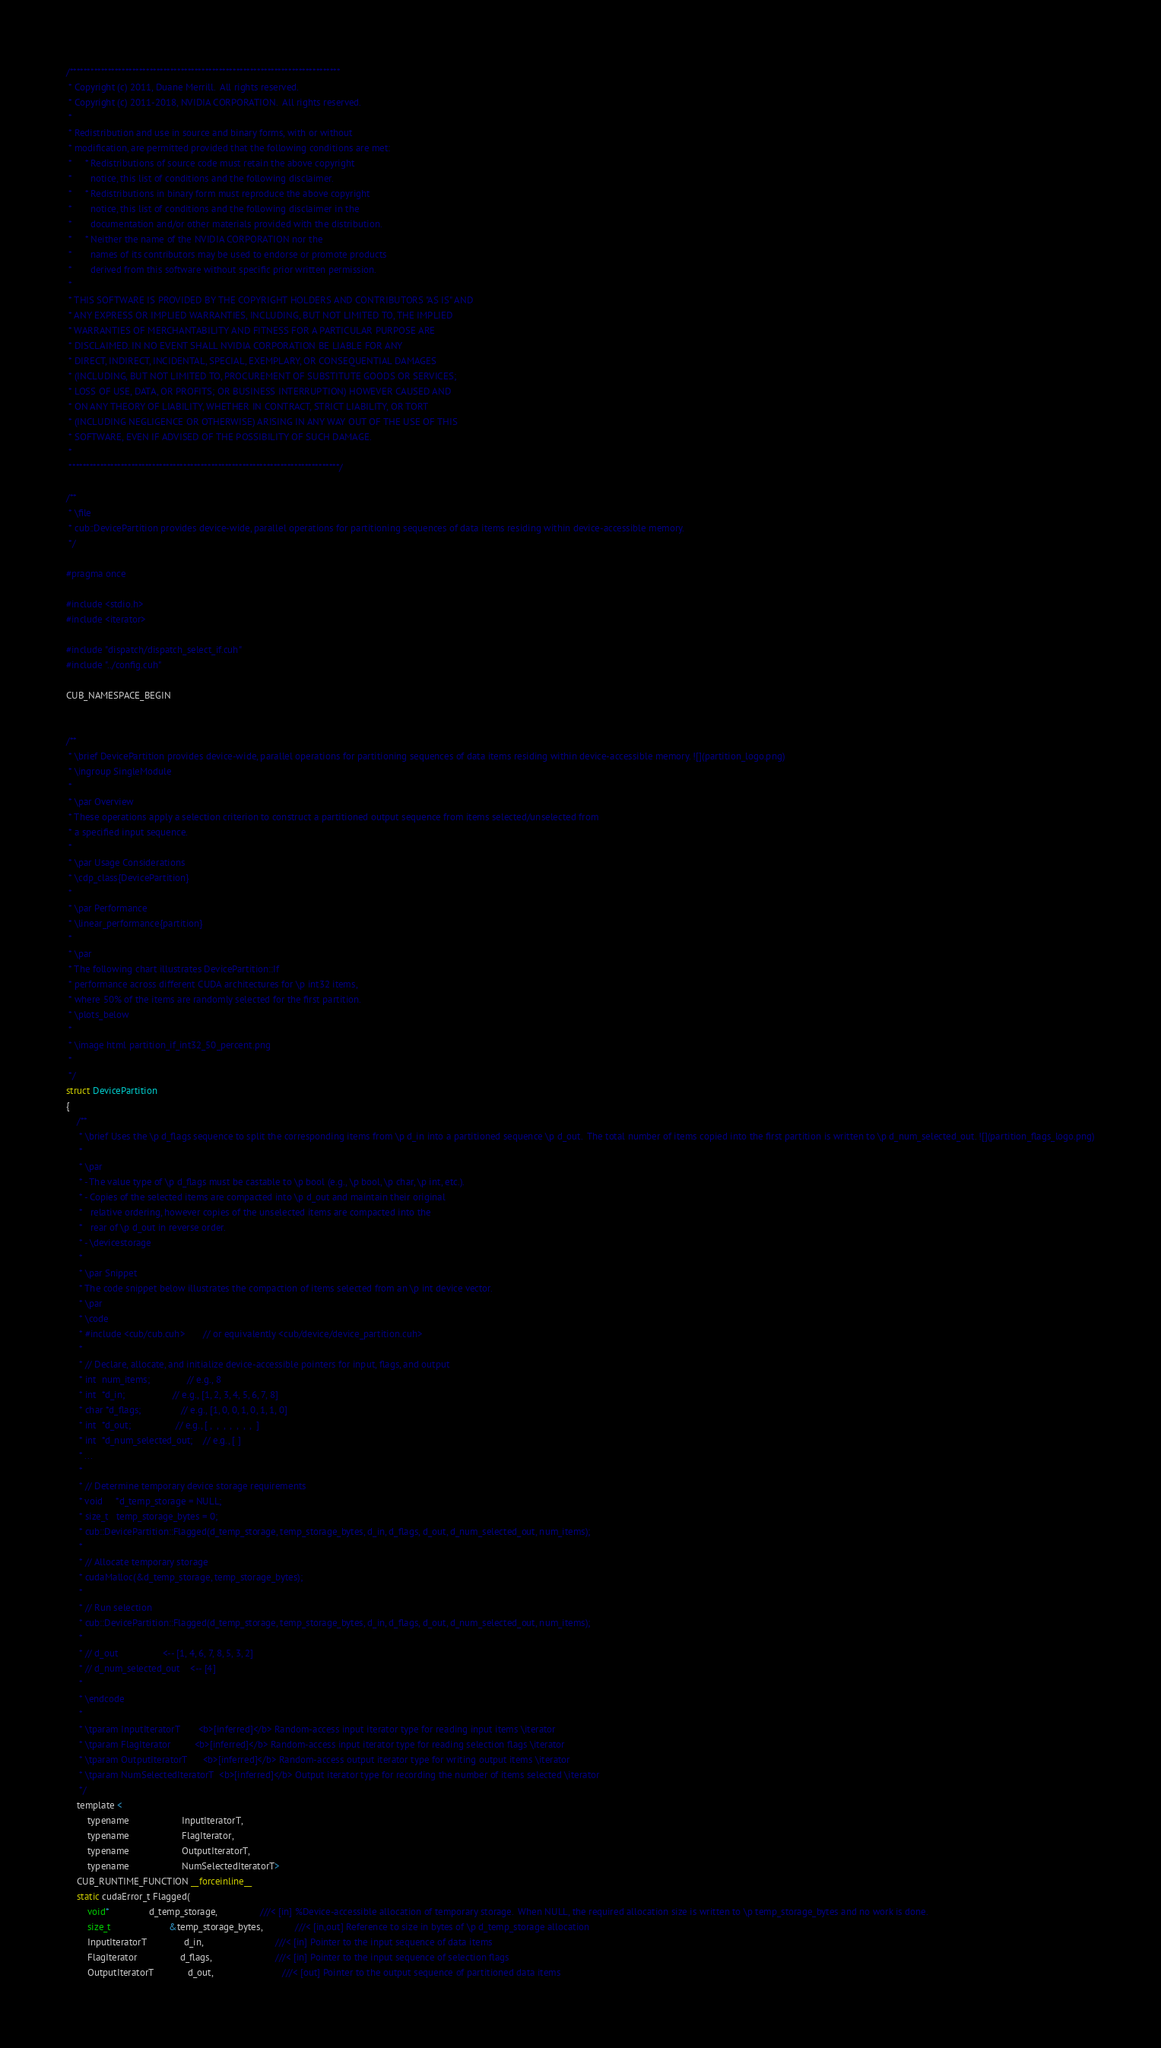Convert code to text. <code><loc_0><loc_0><loc_500><loc_500><_Cuda_>
/******************************************************************************
 * Copyright (c) 2011, Duane Merrill.  All rights reserved.
 * Copyright (c) 2011-2018, NVIDIA CORPORATION.  All rights reserved.
 *
 * Redistribution and use in source and binary forms, with or without
 * modification, are permitted provided that the following conditions are met:
 *     * Redistributions of source code must retain the above copyright
 *       notice, this list of conditions and the following disclaimer.
 *     * Redistributions in binary form must reproduce the above copyright
 *       notice, this list of conditions and the following disclaimer in the
 *       documentation and/or other materials provided with the distribution.
 *     * Neither the name of the NVIDIA CORPORATION nor the
 *       names of its contributors may be used to endorse or promote products
 *       derived from this software without specific prior written permission.
 *
 * THIS SOFTWARE IS PROVIDED BY THE COPYRIGHT HOLDERS AND CONTRIBUTORS "AS IS" AND
 * ANY EXPRESS OR IMPLIED WARRANTIES, INCLUDING, BUT NOT LIMITED TO, THE IMPLIED
 * WARRANTIES OF MERCHANTABILITY AND FITNESS FOR A PARTICULAR PURPOSE ARE
 * DISCLAIMED. IN NO EVENT SHALL NVIDIA CORPORATION BE LIABLE FOR ANY
 * DIRECT, INDIRECT, INCIDENTAL, SPECIAL, EXEMPLARY, OR CONSEQUENTIAL DAMAGES
 * (INCLUDING, BUT NOT LIMITED TO, PROCUREMENT OF SUBSTITUTE GOODS OR SERVICES;
 * LOSS OF USE, DATA, OR PROFITS; OR BUSINESS INTERRUPTION) HOWEVER CAUSED AND
 * ON ANY THEORY OF LIABILITY, WHETHER IN CONTRACT, STRICT LIABILITY, OR TORT
 * (INCLUDING NEGLIGENCE OR OTHERWISE) ARISING IN ANY WAY OUT OF THE USE OF THIS
 * SOFTWARE, EVEN IF ADVISED OF THE POSSIBILITY OF SUCH DAMAGE.
 *
 ******************************************************************************/

/**
 * \file
 * cub::DevicePartition provides device-wide, parallel operations for partitioning sequences of data items residing within device-accessible memory.
 */

#pragma once

#include <stdio.h>
#include <iterator>

#include "dispatch/dispatch_select_if.cuh"
#include "../config.cuh"

CUB_NAMESPACE_BEGIN


/**
 * \brief DevicePartition provides device-wide, parallel operations for partitioning sequences of data items residing within device-accessible memory. ![](partition_logo.png)
 * \ingroup SingleModule
 *
 * \par Overview
 * These operations apply a selection criterion to construct a partitioned output sequence from items selected/unselected from
 * a specified input sequence.
 *
 * \par Usage Considerations
 * \cdp_class{DevicePartition}
 *
 * \par Performance
 * \linear_performance{partition}
 *
 * \par
 * The following chart illustrates DevicePartition::If
 * performance across different CUDA architectures for \p int32 items,
 * where 50% of the items are randomly selected for the first partition.
 * \plots_below
 *
 * \image html partition_if_int32_50_percent.png
 *
 */
struct DevicePartition
{
    /**
     * \brief Uses the \p d_flags sequence to split the corresponding items from \p d_in into a partitioned sequence \p d_out.  The total number of items copied into the first partition is written to \p d_num_selected_out. ![](partition_flags_logo.png)
     *
     * \par
     * - The value type of \p d_flags must be castable to \p bool (e.g., \p bool, \p char, \p int, etc.).
     * - Copies of the selected items are compacted into \p d_out and maintain their original
     *   relative ordering, however copies of the unselected items are compacted into the
     *   rear of \p d_out in reverse order.
     * - \devicestorage
     *
     * \par Snippet
     * The code snippet below illustrates the compaction of items selected from an \p int device vector.
     * \par
     * \code
     * #include <cub/cub.cuh>       // or equivalently <cub/device/device_partition.cuh>
     *
     * // Declare, allocate, and initialize device-accessible pointers for input, flags, and output
     * int  num_items;              // e.g., 8
     * int  *d_in;                  // e.g., [1, 2, 3, 4, 5, 6, 7, 8]
     * char *d_flags;               // e.g., [1, 0, 0, 1, 0, 1, 1, 0]
     * int  *d_out;                 // e.g., [ ,  ,  ,  ,  ,  ,  ,  ]
     * int  *d_num_selected_out;    // e.g., [ ]
     * ...
     *
     * // Determine temporary device storage requirements
     * void     *d_temp_storage = NULL;
     * size_t   temp_storage_bytes = 0;
     * cub::DevicePartition::Flagged(d_temp_storage, temp_storage_bytes, d_in, d_flags, d_out, d_num_selected_out, num_items);
     *
     * // Allocate temporary storage
     * cudaMalloc(&d_temp_storage, temp_storage_bytes);
     *
     * // Run selection
     * cub::DevicePartition::Flagged(d_temp_storage, temp_storage_bytes, d_in, d_flags, d_out, d_num_selected_out, num_items);
     *
     * // d_out                 <-- [1, 4, 6, 7, 8, 5, 3, 2]
     * // d_num_selected_out    <-- [4]
     *
     * \endcode
     *
     * \tparam InputIteratorT       <b>[inferred]</b> Random-access input iterator type for reading input items \iterator
     * \tparam FlagIterator         <b>[inferred]</b> Random-access input iterator type for reading selection flags \iterator
     * \tparam OutputIteratorT      <b>[inferred]</b> Random-access output iterator type for writing output items \iterator
     * \tparam NumSelectedIteratorT  <b>[inferred]</b> Output iterator type for recording the number of items selected \iterator
     */
    template <
        typename                    InputIteratorT,
        typename                    FlagIterator,
        typename                    OutputIteratorT,
        typename                    NumSelectedIteratorT>
    CUB_RUNTIME_FUNCTION __forceinline__
    static cudaError_t Flagged(
        void*               d_temp_storage,                ///< [in] %Device-accessible allocation of temporary storage.  When NULL, the required allocation size is written to \p temp_storage_bytes and no work is done.
        size_t                      &temp_storage_bytes,            ///< [in,out] Reference to size in bytes of \p d_temp_storage allocation
        InputIteratorT              d_in,                           ///< [in] Pointer to the input sequence of data items
        FlagIterator                d_flags,                        ///< [in] Pointer to the input sequence of selection flags
        OutputIteratorT             d_out,                          ///< [out] Pointer to the output sequence of partitioned data items</code> 